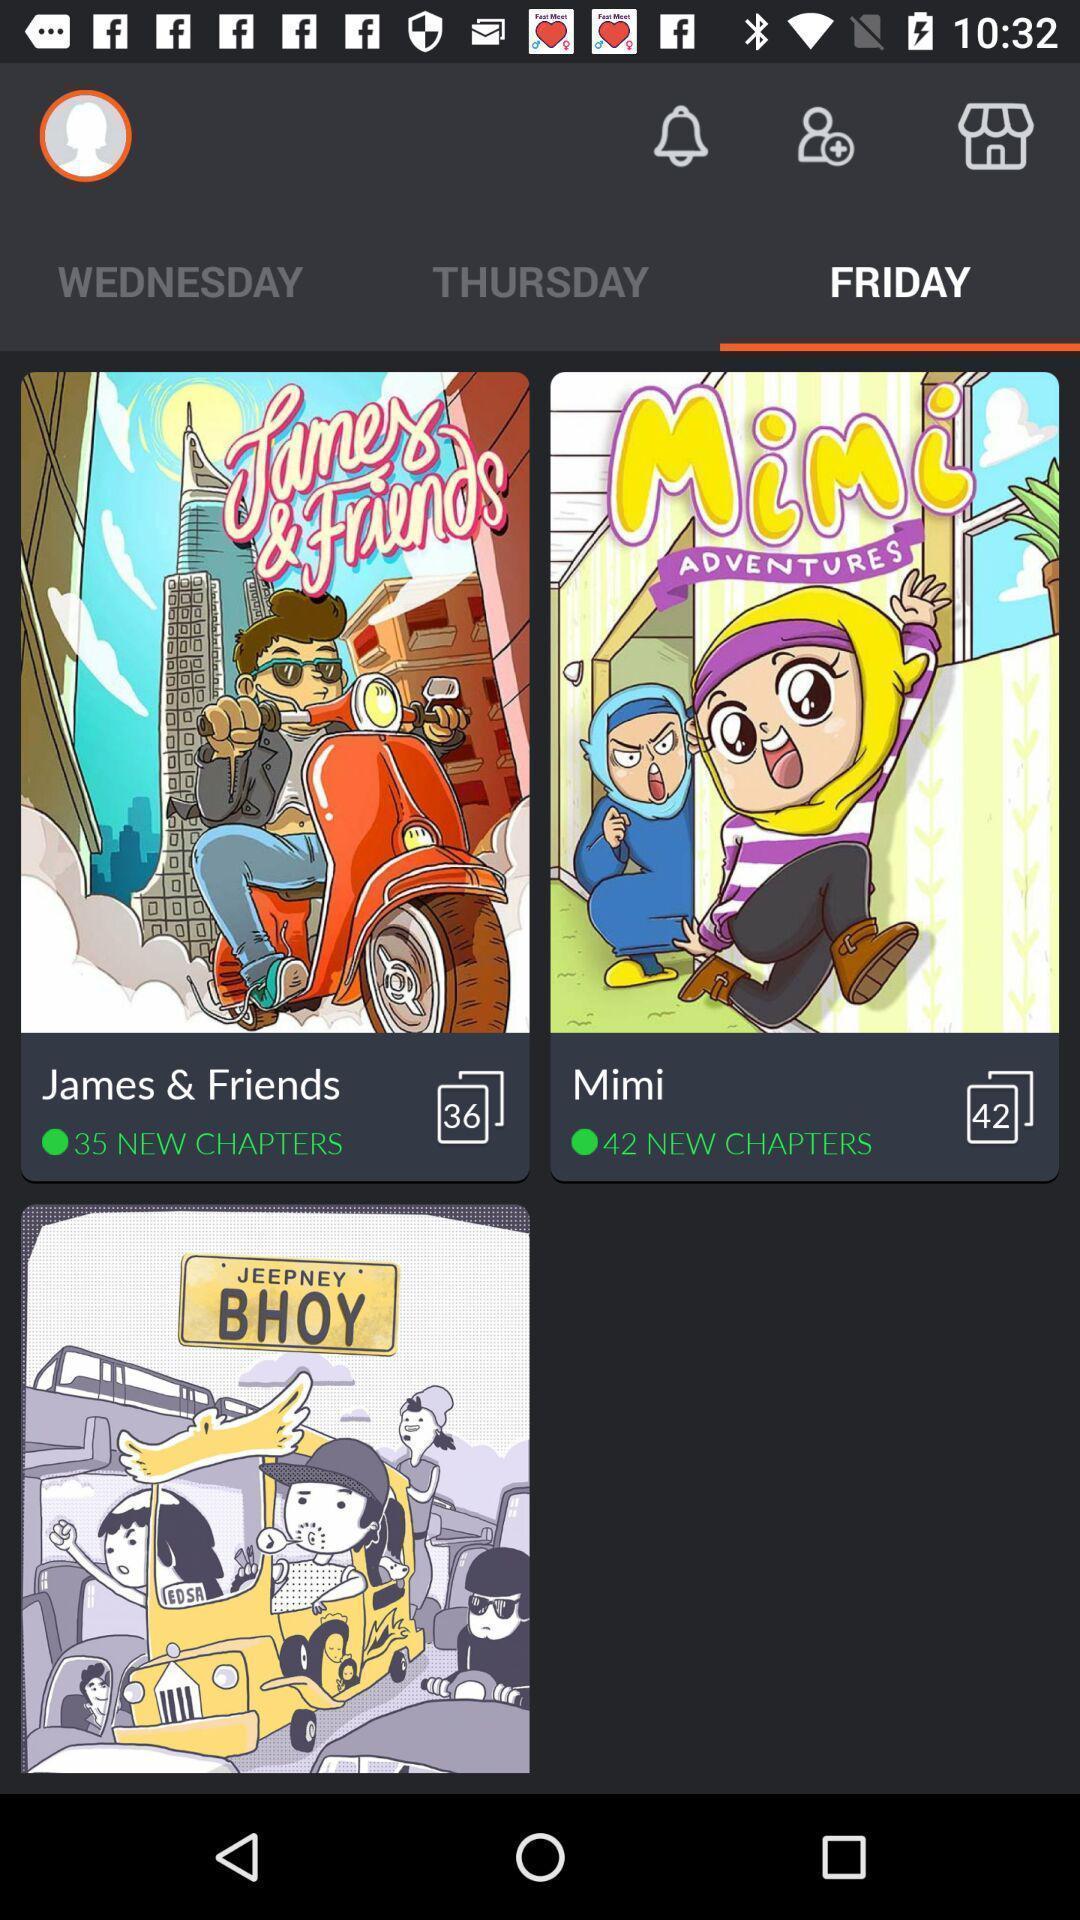Describe this image in words. Various story book displayed as per day. 